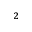<formula> <loc_0><loc_0><loc_500><loc_500>^ { 2 }</formula> 